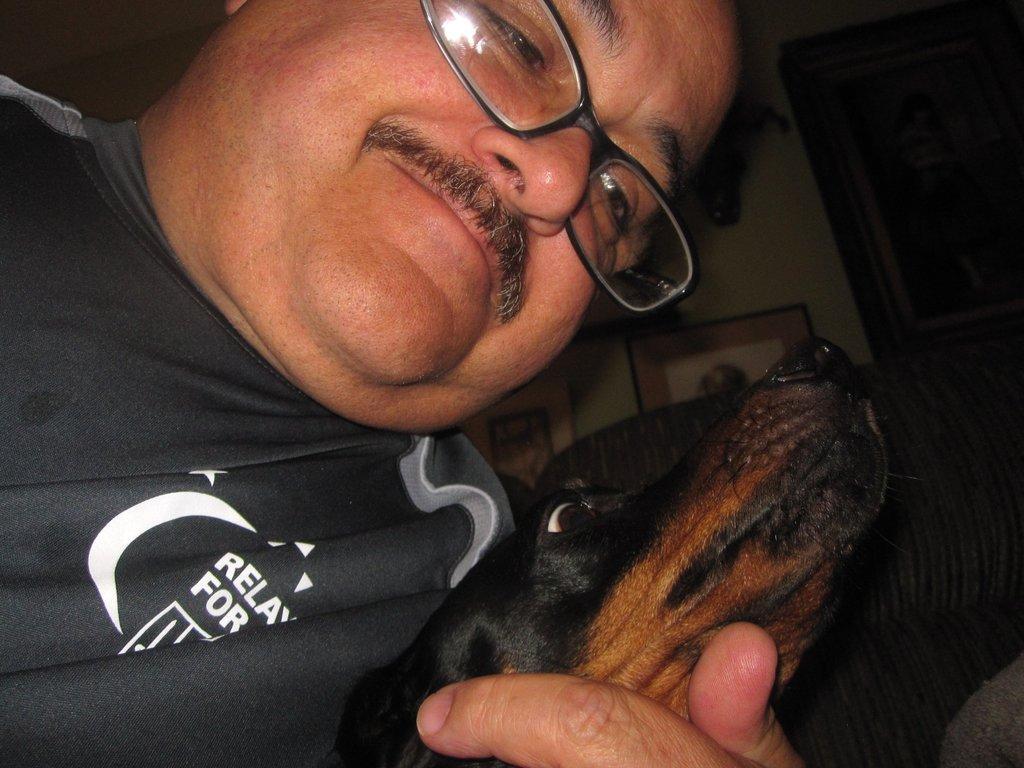Could you give a brief overview of what you see in this image? We can see a man is holding a dog in his hand. In the background there is an object on the chair and frames and objects on the wall. 